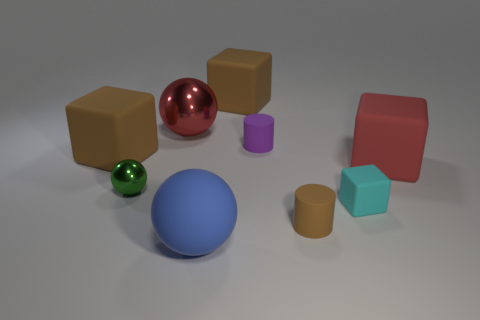Subtract 1 balls. How many balls are left? 2 Add 1 red rubber objects. How many objects exist? 10 Subtract all blue blocks. Subtract all cyan cylinders. How many blocks are left? 4 Subtract all cubes. How many objects are left? 5 Add 5 red rubber things. How many red rubber things exist? 6 Subtract 1 blue spheres. How many objects are left? 8 Subtract all large cubes. Subtract all large red matte cubes. How many objects are left? 5 Add 5 big metallic spheres. How many big metallic spheres are left? 6 